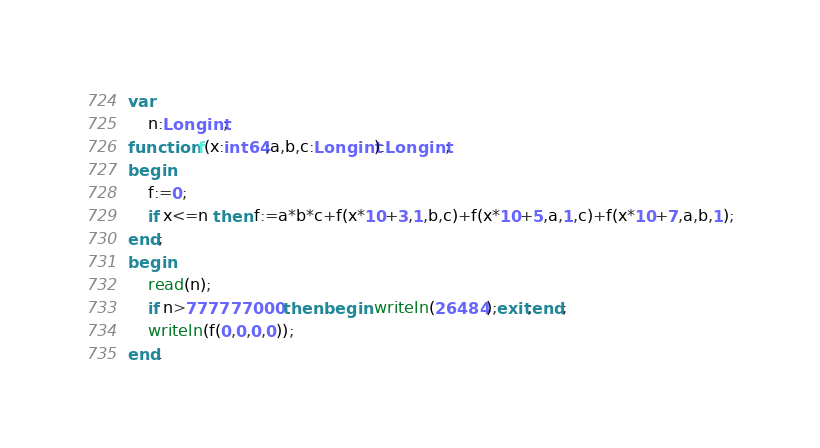Convert code to text. <code><loc_0><loc_0><loc_500><loc_500><_Pascal_>var
	n:Longint;
function f(x:int64;a,b,c:Longint):Longint;
begin
	f:=0;
	if x<=n then f:=a*b*c+f(x*10+3,1,b,c)+f(x*10+5,a,1,c)+f(x*10+7,a,b,1);
end;
begin
	read(n);
	if n>777777000 then begin writeln(26484);exit;end;
	writeln(f(0,0,0,0));
end.</code> 